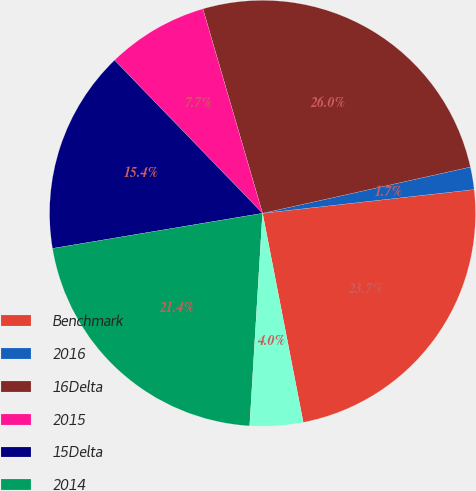Convert chart to OTSL. <chart><loc_0><loc_0><loc_500><loc_500><pie_chart><fcel>Benchmark<fcel>2016<fcel>16Delta<fcel>2015<fcel>15Delta<fcel>2014<fcel>14Delta<nl><fcel>23.72%<fcel>1.71%<fcel>26.03%<fcel>7.71%<fcel>15.41%<fcel>21.4%<fcel>4.02%<nl></chart> 